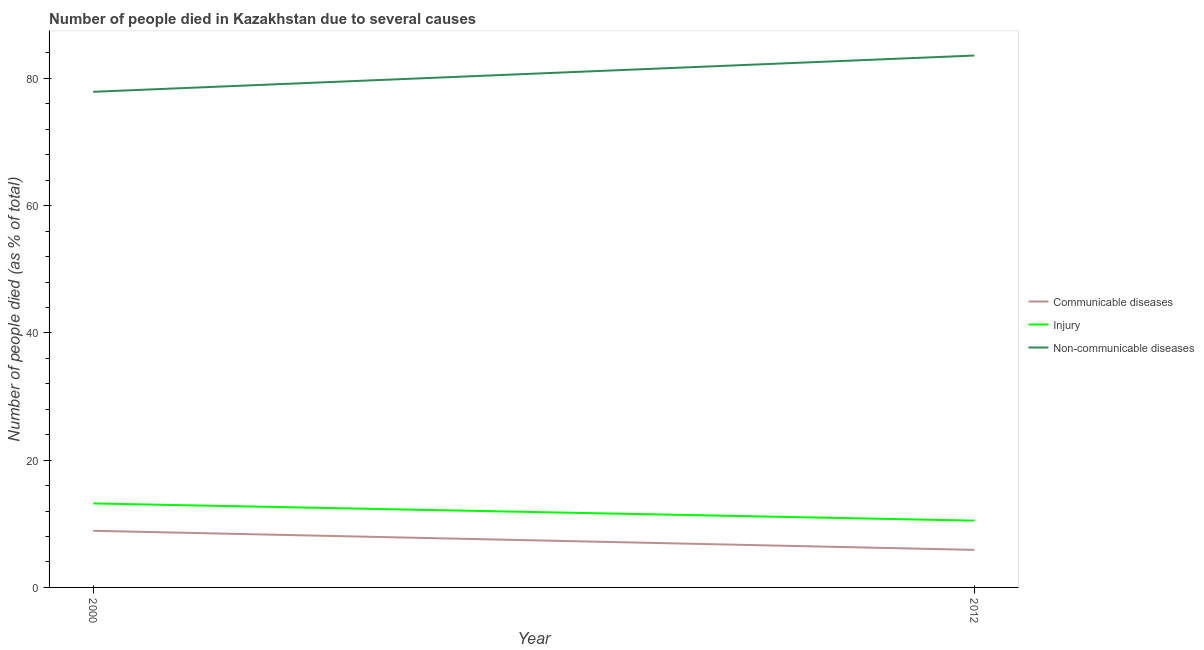How many different coloured lines are there?
Offer a very short reply. 3. Across all years, what is the minimum number of people who died of communicable diseases?
Provide a succinct answer. 5.9. What is the total number of people who dies of non-communicable diseases in the graph?
Provide a short and direct response. 161.5. What is the difference between the number of people who died of injury in 2000 and that in 2012?
Offer a terse response. 2.7. What is the difference between the number of people who died of communicable diseases in 2012 and the number of people who died of injury in 2000?
Offer a terse response. -7.3. What is the average number of people who dies of non-communicable diseases per year?
Ensure brevity in your answer.  80.75. In the year 2012, what is the difference between the number of people who dies of non-communicable diseases and number of people who died of injury?
Ensure brevity in your answer.  73.1. In how many years, is the number of people who died of communicable diseases greater than 36 %?
Ensure brevity in your answer.  0. What is the ratio of the number of people who dies of non-communicable diseases in 2000 to that in 2012?
Keep it short and to the point. 0.93. Is the number of people who died of injury in 2000 less than that in 2012?
Your answer should be very brief. No. In how many years, is the number of people who died of injury greater than the average number of people who died of injury taken over all years?
Offer a very short reply. 1. Does the number of people who died of injury monotonically increase over the years?
Make the answer very short. No. Is the number of people who dies of non-communicable diseases strictly greater than the number of people who died of communicable diseases over the years?
Make the answer very short. Yes. Is the number of people who died of communicable diseases strictly less than the number of people who died of injury over the years?
Keep it short and to the point. Yes. Are the values on the major ticks of Y-axis written in scientific E-notation?
Give a very brief answer. No. Does the graph contain any zero values?
Provide a succinct answer. No. How many legend labels are there?
Your response must be concise. 3. What is the title of the graph?
Give a very brief answer. Number of people died in Kazakhstan due to several causes. What is the label or title of the Y-axis?
Provide a short and direct response. Number of people died (as % of total). What is the Number of people died (as % of total) in Communicable diseases in 2000?
Offer a terse response. 8.9. What is the Number of people died (as % of total) of Non-communicable diseases in 2000?
Offer a very short reply. 77.9. What is the Number of people died (as % of total) of Communicable diseases in 2012?
Provide a succinct answer. 5.9. What is the Number of people died (as % of total) of Non-communicable diseases in 2012?
Keep it short and to the point. 83.6. Across all years, what is the maximum Number of people died (as % of total) in Injury?
Your answer should be compact. 13.2. Across all years, what is the maximum Number of people died (as % of total) in Non-communicable diseases?
Your response must be concise. 83.6. Across all years, what is the minimum Number of people died (as % of total) of Injury?
Your answer should be compact. 10.5. Across all years, what is the minimum Number of people died (as % of total) in Non-communicable diseases?
Make the answer very short. 77.9. What is the total Number of people died (as % of total) in Communicable diseases in the graph?
Provide a succinct answer. 14.8. What is the total Number of people died (as % of total) of Injury in the graph?
Ensure brevity in your answer.  23.7. What is the total Number of people died (as % of total) in Non-communicable diseases in the graph?
Provide a succinct answer. 161.5. What is the difference between the Number of people died (as % of total) of Injury in 2000 and that in 2012?
Your answer should be compact. 2.7. What is the difference between the Number of people died (as % of total) of Communicable diseases in 2000 and the Number of people died (as % of total) of Non-communicable diseases in 2012?
Provide a short and direct response. -74.7. What is the difference between the Number of people died (as % of total) of Injury in 2000 and the Number of people died (as % of total) of Non-communicable diseases in 2012?
Your answer should be very brief. -70.4. What is the average Number of people died (as % of total) in Injury per year?
Provide a succinct answer. 11.85. What is the average Number of people died (as % of total) of Non-communicable diseases per year?
Offer a very short reply. 80.75. In the year 2000, what is the difference between the Number of people died (as % of total) in Communicable diseases and Number of people died (as % of total) in Non-communicable diseases?
Your answer should be compact. -69. In the year 2000, what is the difference between the Number of people died (as % of total) in Injury and Number of people died (as % of total) in Non-communicable diseases?
Offer a very short reply. -64.7. In the year 2012, what is the difference between the Number of people died (as % of total) of Communicable diseases and Number of people died (as % of total) of Non-communicable diseases?
Provide a succinct answer. -77.7. In the year 2012, what is the difference between the Number of people died (as % of total) in Injury and Number of people died (as % of total) in Non-communicable diseases?
Offer a very short reply. -73.1. What is the ratio of the Number of people died (as % of total) of Communicable diseases in 2000 to that in 2012?
Offer a very short reply. 1.51. What is the ratio of the Number of people died (as % of total) of Injury in 2000 to that in 2012?
Provide a succinct answer. 1.26. What is the ratio of the Number of people died (as % of total) in Non-communicable diseases in 2000 to that in 2012?
Keep it short and to the point. 0.93. What is the difference between the highest and the lowest Number of people died (as % of total) of Communicable diseases?
Offer a very short reply. 3. What is the difference between the highest and the lowest Number of people died (as % of total) of Injury?
Your answer should be very brief. 2.7. 